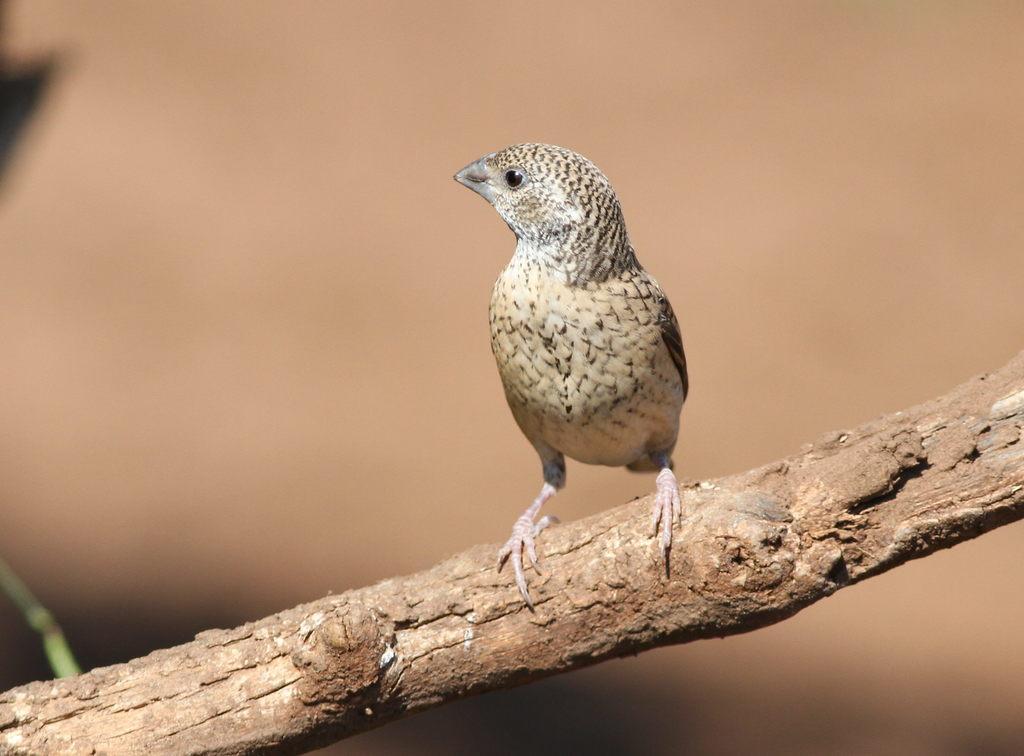Can you describe this image briefly? Here, at the middle we can see a woodpecker finch sitting on a stick. 